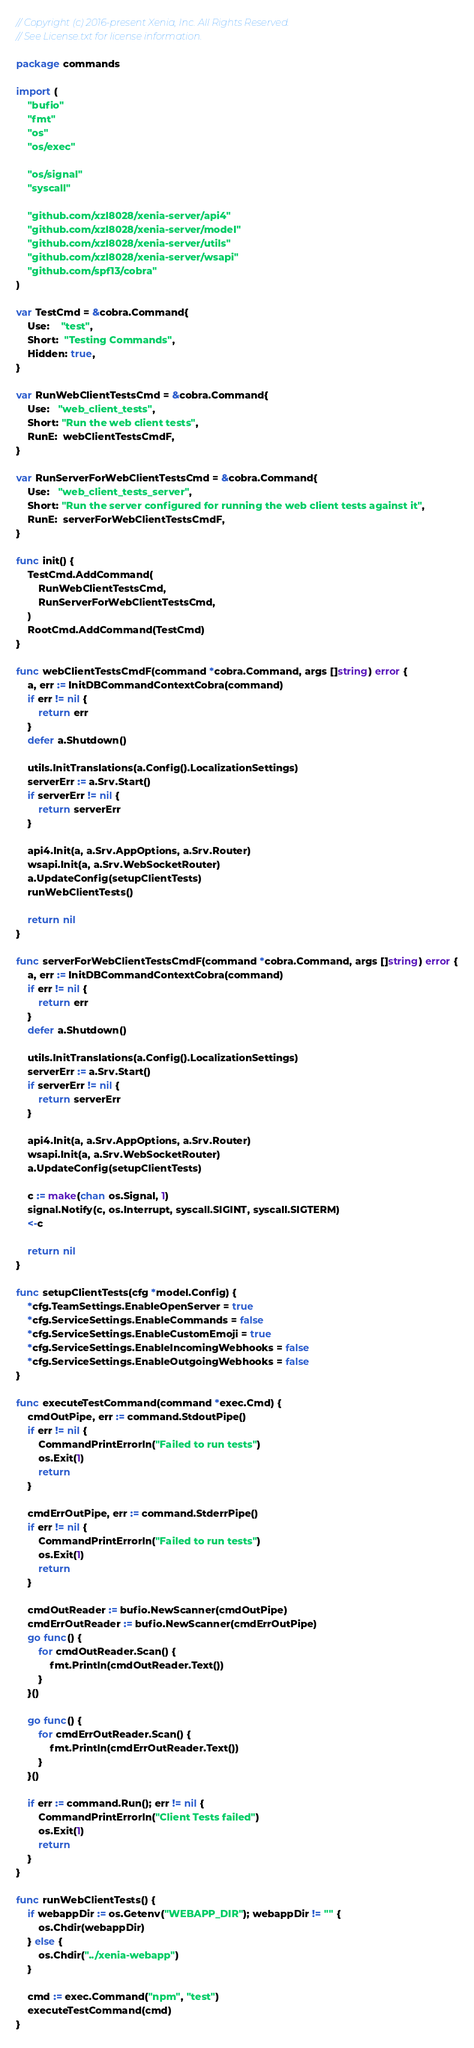<code> <loc_0><loc_0><loc_500><loc_500><_Go_>// Copyright (c) 2016-present Xenia, Inc. All Rights Reserved.
// See License.txt for license information.

package commands

import (
	"bufio"
	"fmt"
	"os"
	"os/exec"

	"os/signal"
	"syscall"

	"github.com/xzl8028/xenia-server/api4"
	"github.com/xzl8028/xenia-server/model"
	"github.com/xzl8028/xenia-server/utils"
	"github.com/xzl8028/xenia-server/wsapi"
	"github.com/spf13/cobra"
)

var TestCmd = &cobra.Command{
	Use:    "test",
	Short:  "Testing Commands",
	Hidden: true,
}

var RunWebClientTestsCmd = &cobra.Command{
	Use:   "web_client_tests",
	Short: "Run the web client tests",
	RunE:  webClientTestsCmdF,
}

var RunServerForWebClientTestsCmd = &cobra.Command{
	Use:   "web_client_tests_server",
	Short: "Run the server configured for running the web client tests against it",
	RunE:  serverForWebClientTestsCmdF,
}

func init() {
	TestCmd.AddCommand(
		RunWebClientTestsCmd,
		RunServerForWebClientTestsCmd,
	)
	RootCmd.AddCommand(TestCmd)
}

func webClientTestsCmdF(command *cobra.Command, args []string) error {
	a, err := InitDBCommandContextCobra(command)
	if err != nil {
		return err
	}
	defer a.Shutdown()

	utils.InitTranslations(a.Config().LocalizationSettings)
	serverErr := a.Srv.Start()
	if serverErr != nil {
		return serverErr
	}

	api4.Init(a, a.Srv.AppOptions, a.Srv.Router)
	wsapi.Init(a, a.Srv.WebSocketRouter)
	a.UpdateConfig(setupClientTests)
	runWebClientTests()

	return nil
}

func serverForWebClientTestsCmdF(command *cobra.Command, args []string) error {
	a, err := InitDBCommandContextCobra(command)
	if err != nil {
		return err
	}
	defer a.Shutdown()

	utils.InitTranslations(a.Config().LocalizationSettings)
	serverErr := a.Srv.Start()
	if serverErr != nil {
		return serverErr
	}

	api4.Init(a, a.Srv.AppOptions, a.Srv.Router)
	wsapi.Init(a, a.Srv.WebSocketRouter)
	a.UpdateConfig(setupClientTests)

	c := make(chan os.Signal, 1)
	signal.Notify(c, os.Interrupt, syscall.SIGINT, syscall.SIGTERM)
	<-c

	return nil
}

func setupClientTests(cfg *model.Config) {
	*cfg.TeamSettings.EnableOpenServer = true
	*cfg.ServiceSettings.EnableCommands = false
	*cfg.ServiceSettings.EnableCustomEmoji = true
	*cfg.ServiceSettings.EnableIncomingWebhooks = false
	*cfg.ServiceSettings.EnableOutgoingWebhooks = false
}

func executeTestCommand(command *exec.Cmd) {
	cmdOutPipe, err := command.StdoutPipe()
	if err != nil {
		CommandPrintErrorln("Failed to run tests")
		os.Exit(1)
		return
	}

	cmdErrOutPipe, err := command.StderrPipe()
	if err != nil {
		CommandPrintErrorln("Failed to run tests")
		os.Exit(1)
		return
	}

	cmdOutReader := bufio.NewScanner(cmdOutPipe)
	cmdErrOutReader := bufio.NewScanner(cmdErrOutPipe)
	go func() {
		for cmdOutReader.Scan() {
			fmt.Println(cmdOutReader.Text())
		}
	}()

	go func() {
		for cmdErrOutReader.Scan() {
			fmt.Println(cmdErrOutReader.Text())
		}
	}()

	if err := command.Run(); err != nil {
		CommandPrintErrorln("Client Tests failed")
		os.Exit(1)
		return
	}
}

func runWebClientTests() {
	if webappDir := os.Getenv("WEBAPP_DIR"); webappDir != "" {
		os.Chdir(webappDir)
	} else {
		os.Chdir("../xenia-webapp")
	}

	cmd := exec.Command("npm", "test")
	executeTestCommand(cmd)
}
</code> 